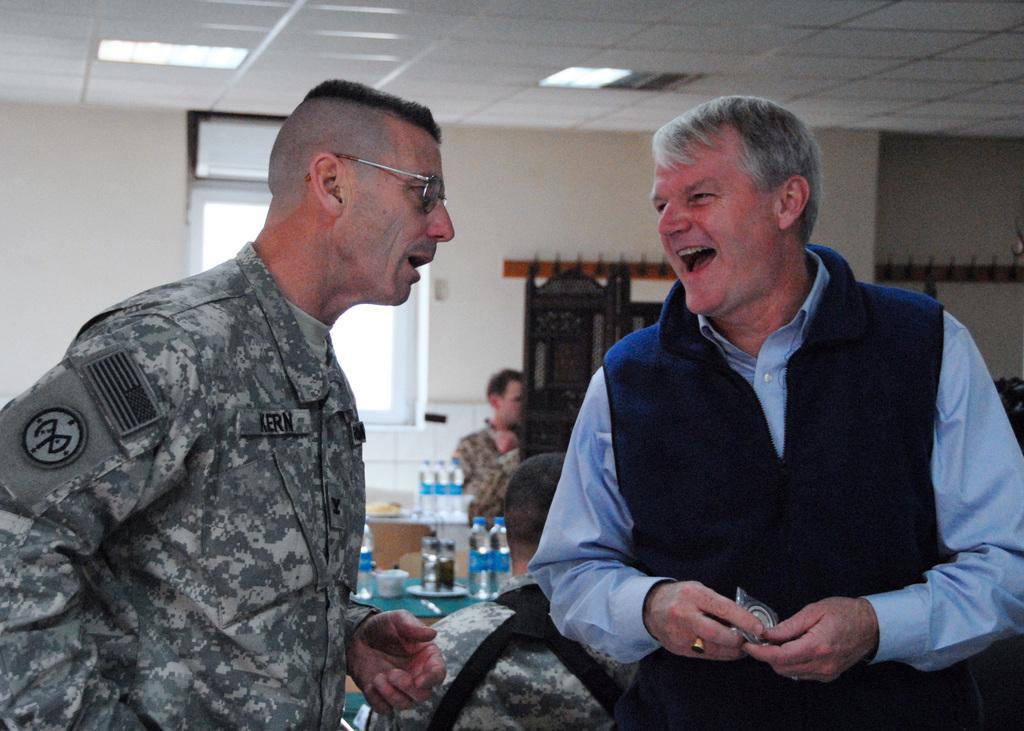In one or two sentences, can you explain what this image depicts? In the picture I can see two persons talking, behind there are few persons, tables and some bottles are placed on it and there is a window to the wall. 